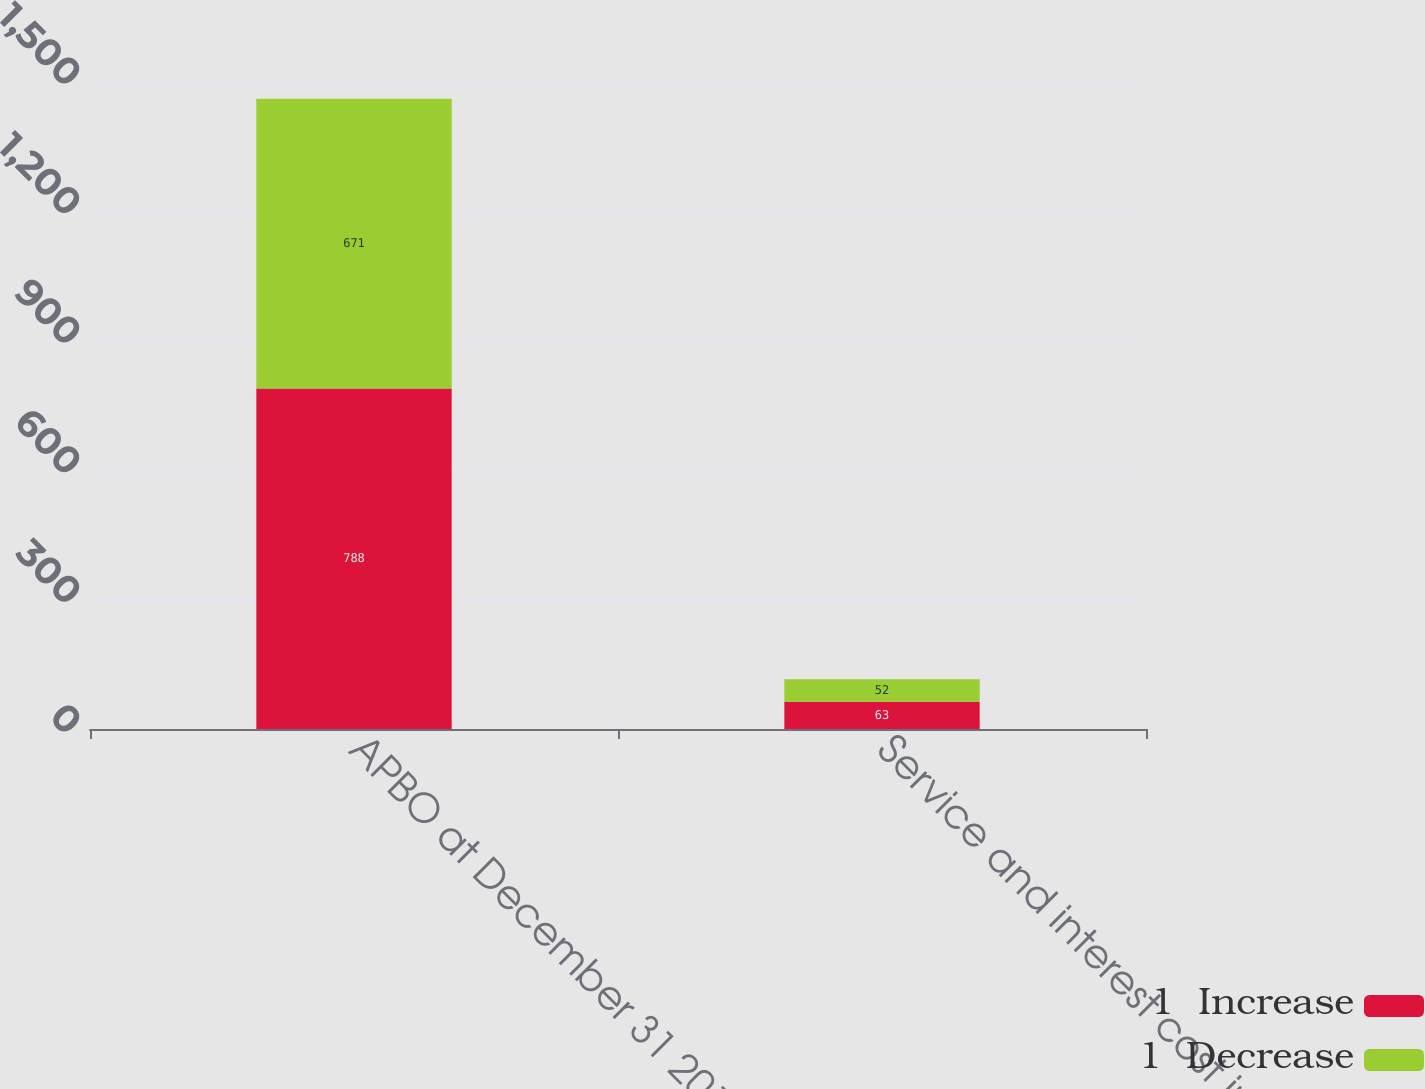Convert chart. <chart><loc_0><loc_0><loc_500><loc_500><stacked_bar_chart><ecel><fcel>APBO at December 31 2013<fcel>Service and interest cost in<nl><fcel>1  Increase<fcel>788<fcel>63<nl><fcel>1  Decrease<fcel>671<fcel>52<nl></chart> 